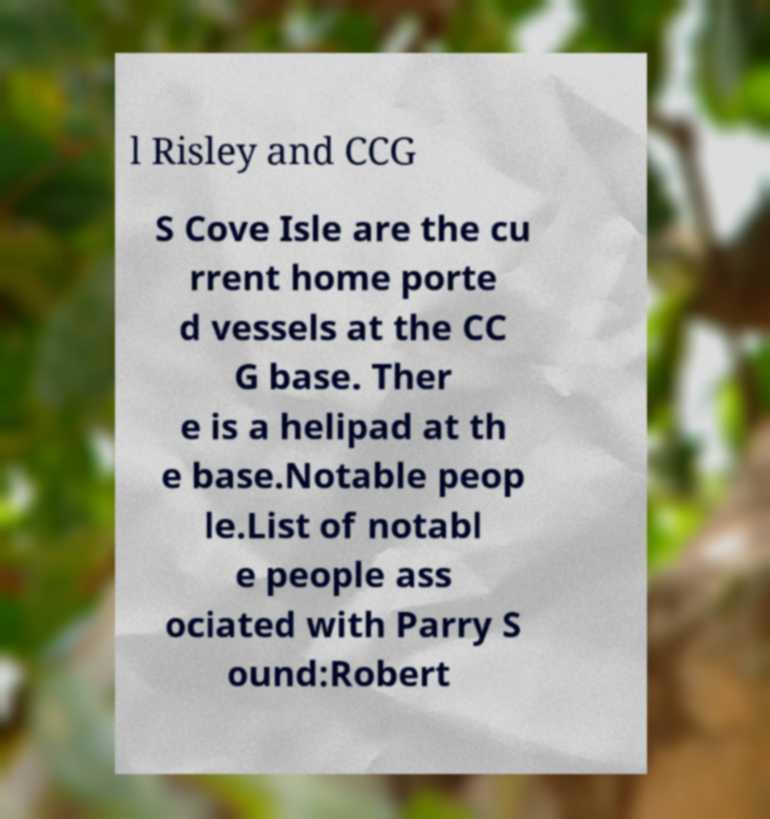For documentation purposes, I need the text within this image transcribed. Could you provide that? l Risley and CCG S Cove Isle are the cu rrent home porte d vessels at the CC G base. Ther e is a helipad at th e base.Notable peop le.List of notabl e people ass ociated with Parry S ound:Robert 